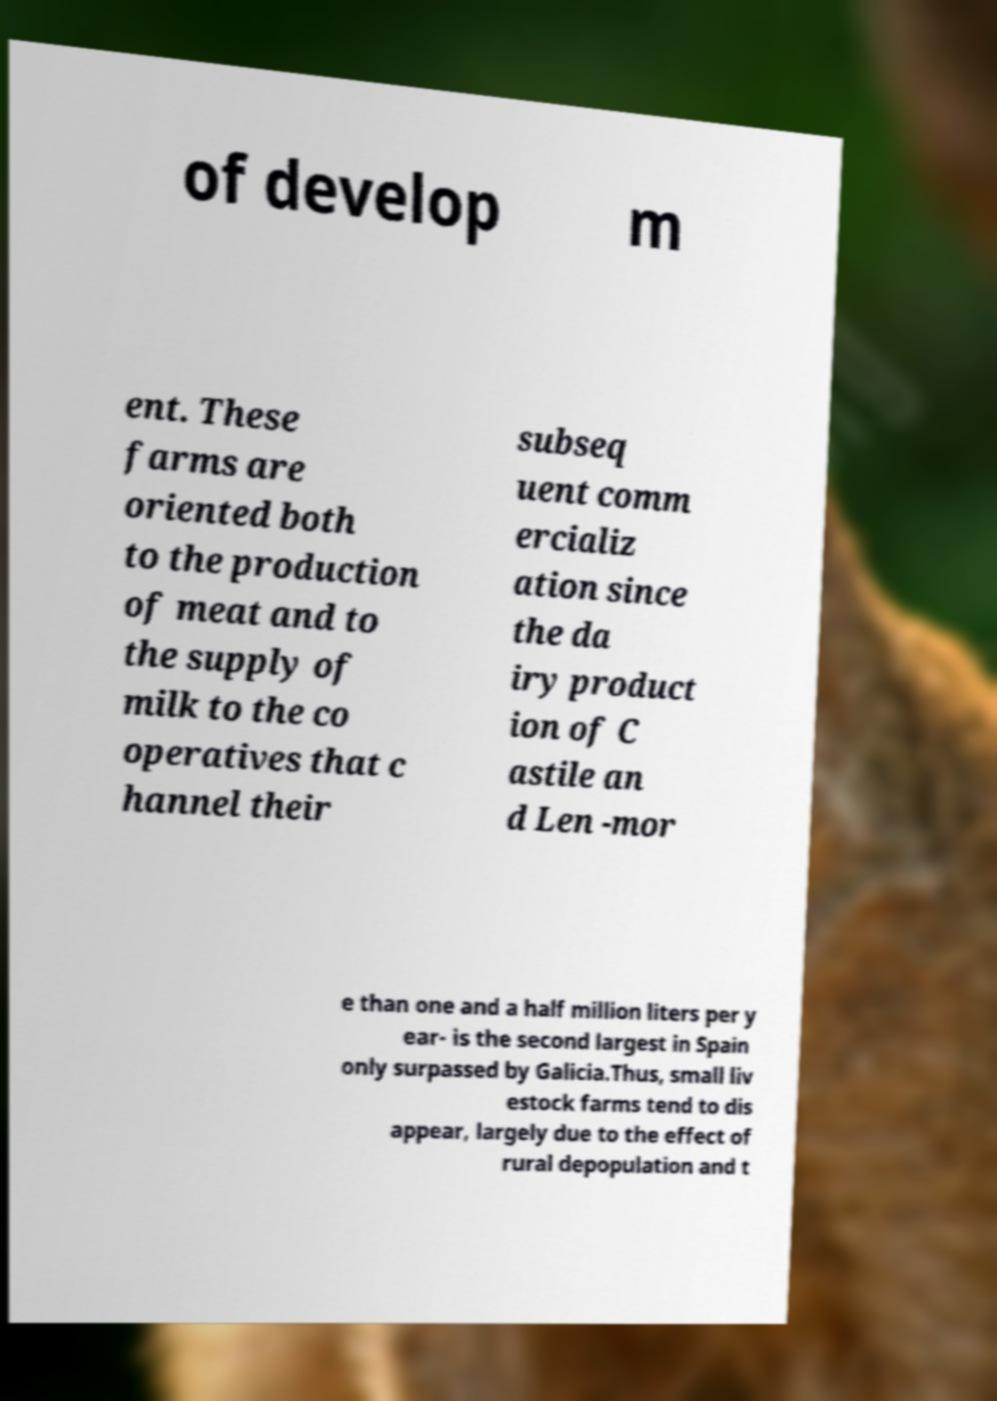Please identify and transcribe the text found in this image. of develop m ent. These farms are oriented both to the production of meat and to the supply of milk to the co operatives that c hannel their subseq uent comm ercializ ation since the da iry product ion of C astile an d Len -mor e than one and a half million liters per y ear- is the second largest in Spain only surpassed by Galicia.Thus, small liv estock farms tend to dis appear, largely due to the effect of rural depopulation and t 